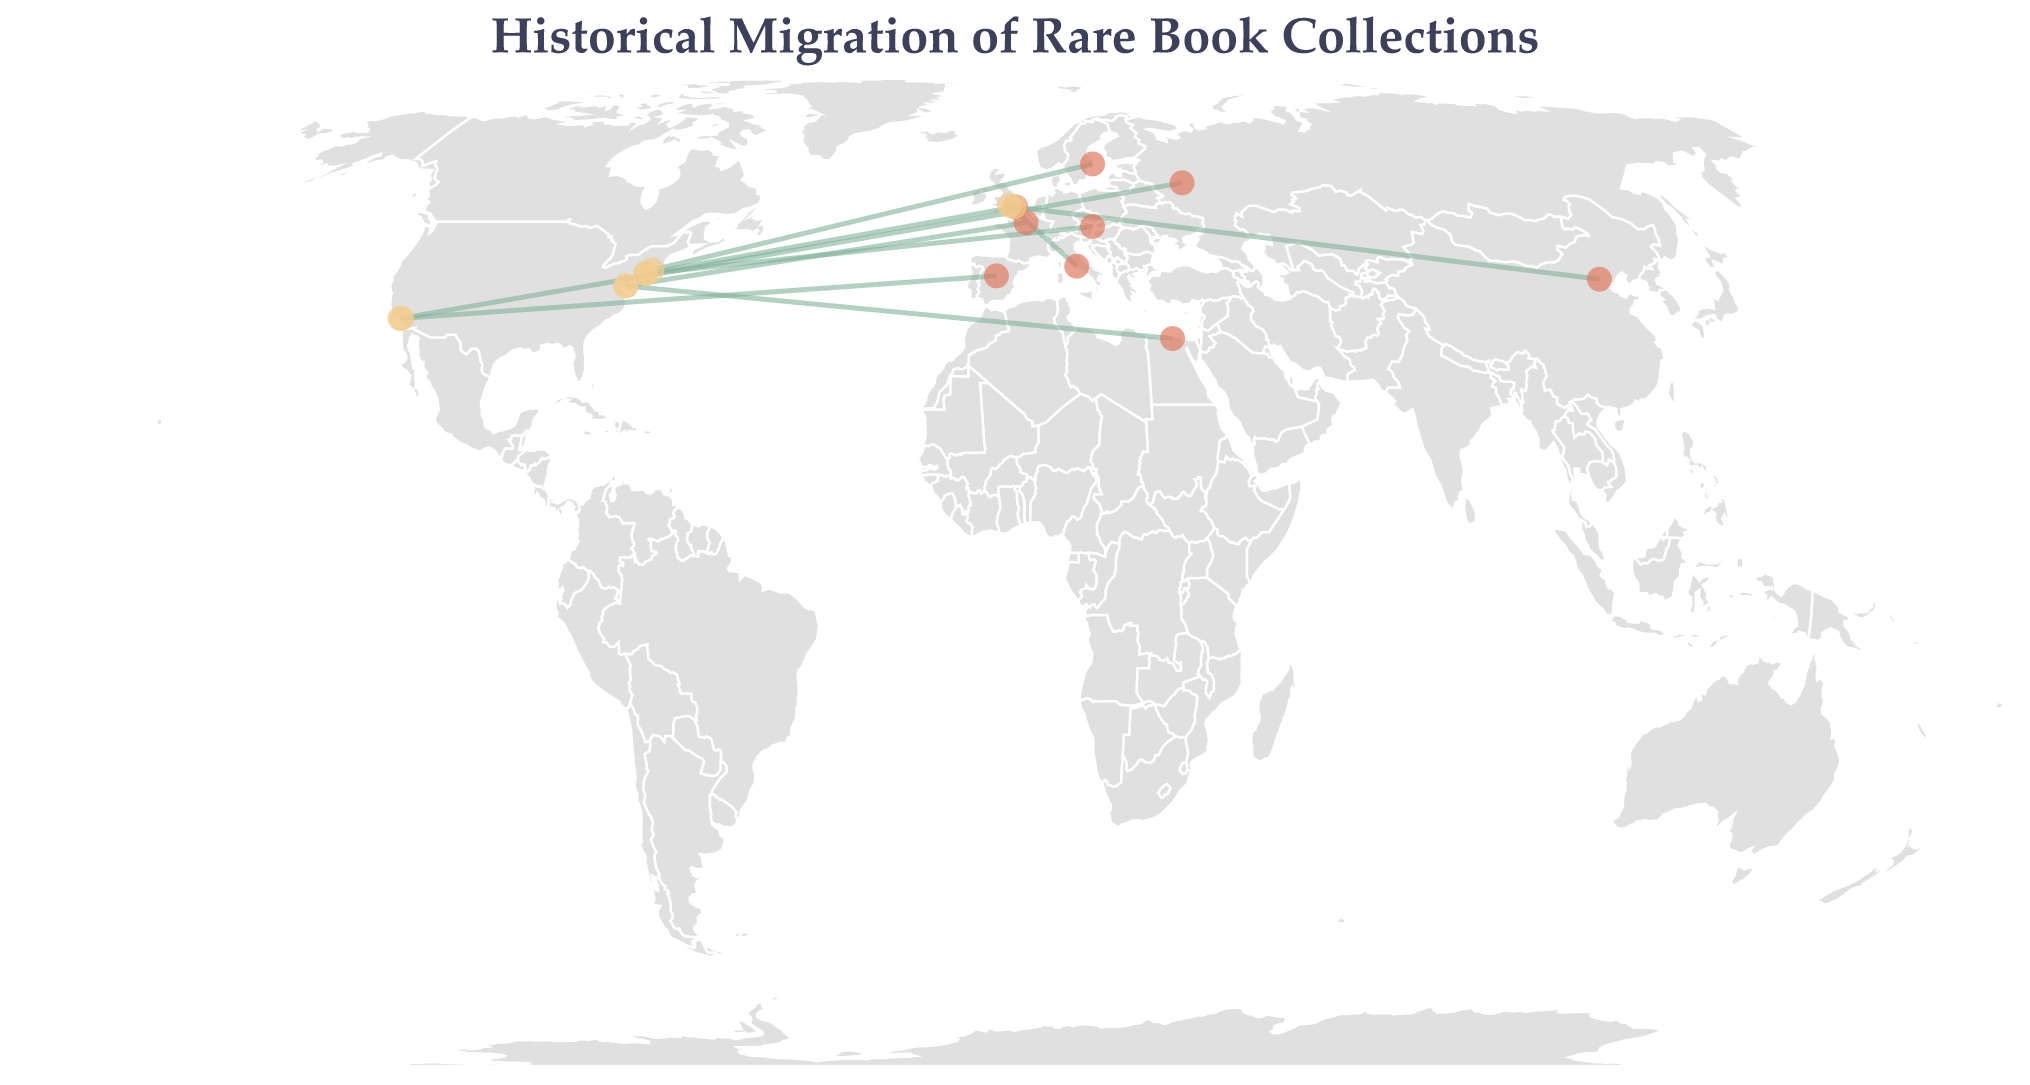What is the title of the plot? The title of the plot is often displayed prominently at the top of the figure. It describes the subject of the plot.
Answer: Historical Migration of Rare Book Collections What is the earliest recorded migration of book collections? Look for the collection with the earliest year in the plot. The timeline often starts from left to right.
Answer: 1920 From which institution did the number of books migrate in 1960, and to which institution did it go? Identify the data point representing the year 1960 and read the corresponding 'From' and 'To' locations from the plot.
Answer: Vatican Library to Bodleian Library How many more books were moved from Bibliothèque nationale de France to the Library of Congress than from the National Library of China to the British Museum? Identify the data points for these two migrations, subtract the number of books in the latter migration from the former migration.
Answer: 31 Which book collection had the highest number of books migrated? Look for the data point with the highest 'Number of Books.'
Answer: Enlightenment Texts Which migration took place most recently? Identify the data point with the most recent year in the timeline presented in the plot.
Answer: 2018 What is the total number of books migrated from European libraries? Sum the number of books originating from European libraries (British Library, Bibliothèque nationale de France, Vatican Library, Russian State Library, National Library of Spain, Austrian National Library, National Library of Sweden).
Answer: 305 Are there more migrations originating from Asia or Europe? Count the number of migrations originating from Asia and compare it with those originating from Europe.
Answer: Europe Which migration involved the "Ancient Egyptian Papyri"? Locate the data point representing the "Ancient Egyptian Papyri" and identify the 'From' and 'To' institutions.
Answer: Library of Alexandria to Smithsonian Libraries 